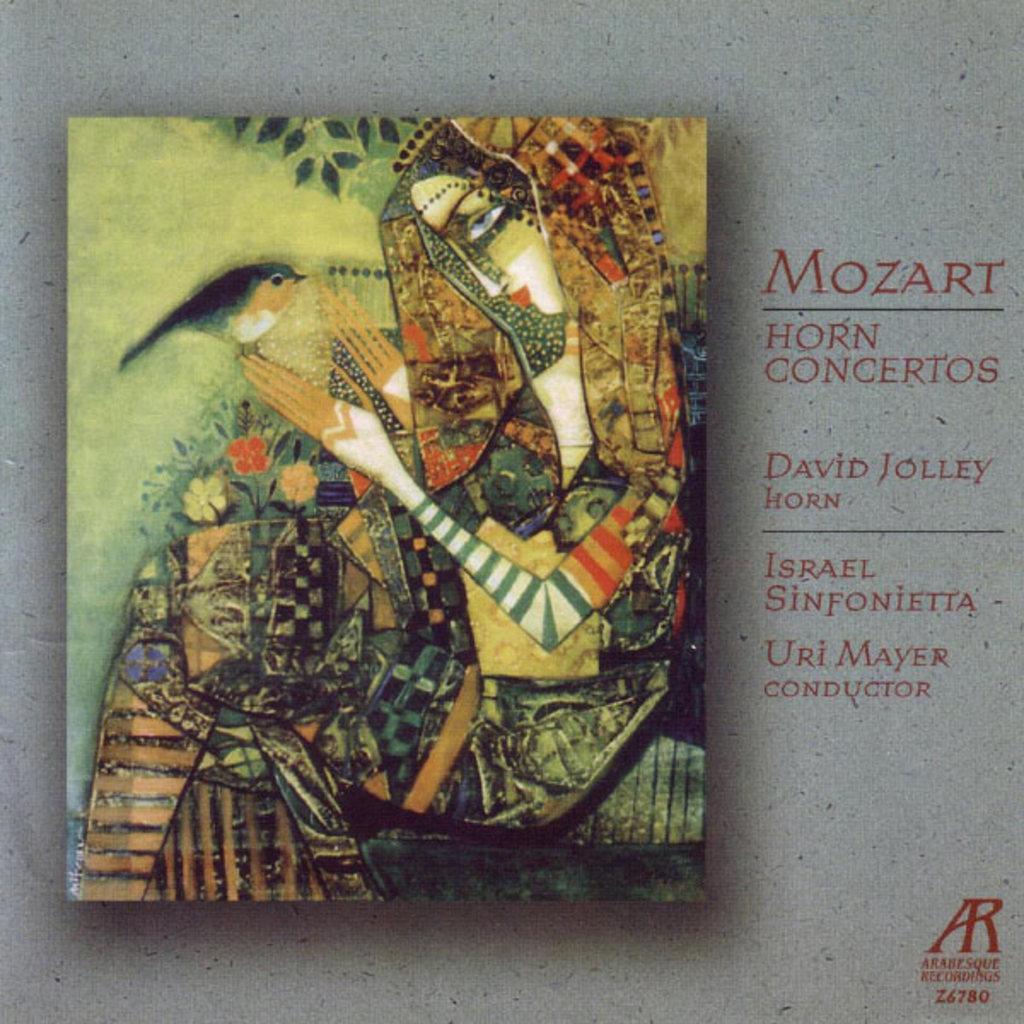Describe this image in one or two sentences. In this image there is a painting of the girl who is holding the bird with her fingers. 